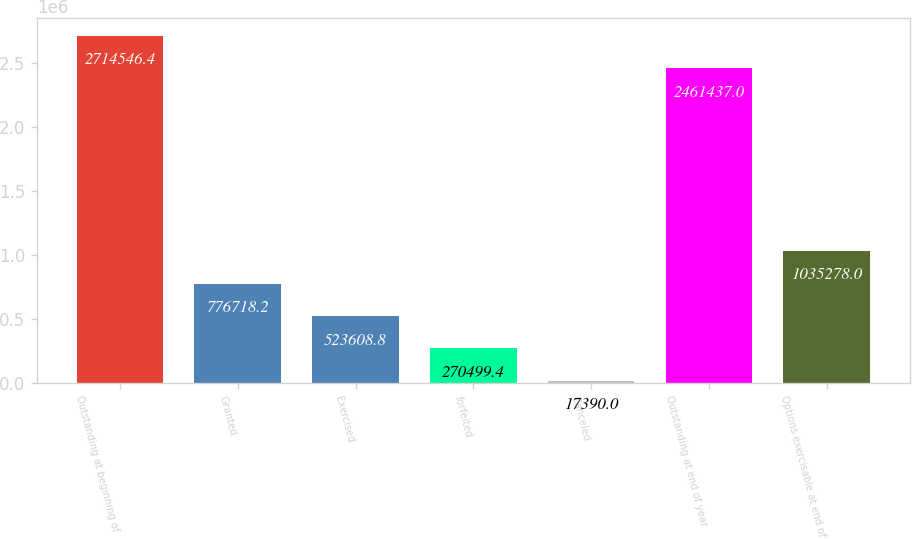Convert chart to OTSL. <chart><loc_0><loc_0><loc_500><loc_500><bar_chart><fcel>Outstanding at beginning of<fcel>Granted<fcel>Exercised<fcel>forfeited<fcel>Canceled<fcel>Outstanding at end of year<fcel>Options exercisable at end of<nl><fcel>2.71455e+06<fcel>776718<fcel>523609<fcel>270499<fcel>17390<fcel>2.46144e+06<fcel>1.03528e+06<nl></chart> 